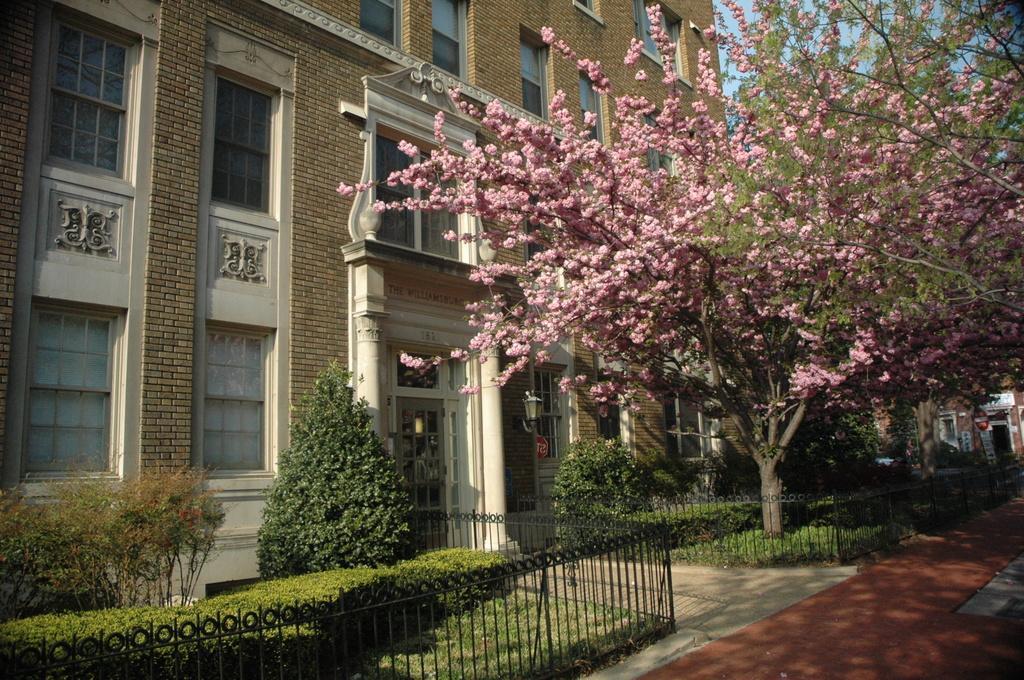Describe this image in one or two sentences. In the picture we can see a building with glass windows and door and near to it, we can see some plants, grass and around it we can see a railing and on the grass surface we can see a tree with pink flowers. 